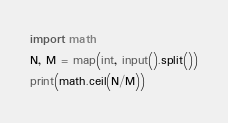<code> <loc_0><loc_0><loc_500><loc_500><_Python_>import math
N, M = map(int, input().split())
print(math.ceil(N/M))</code> 